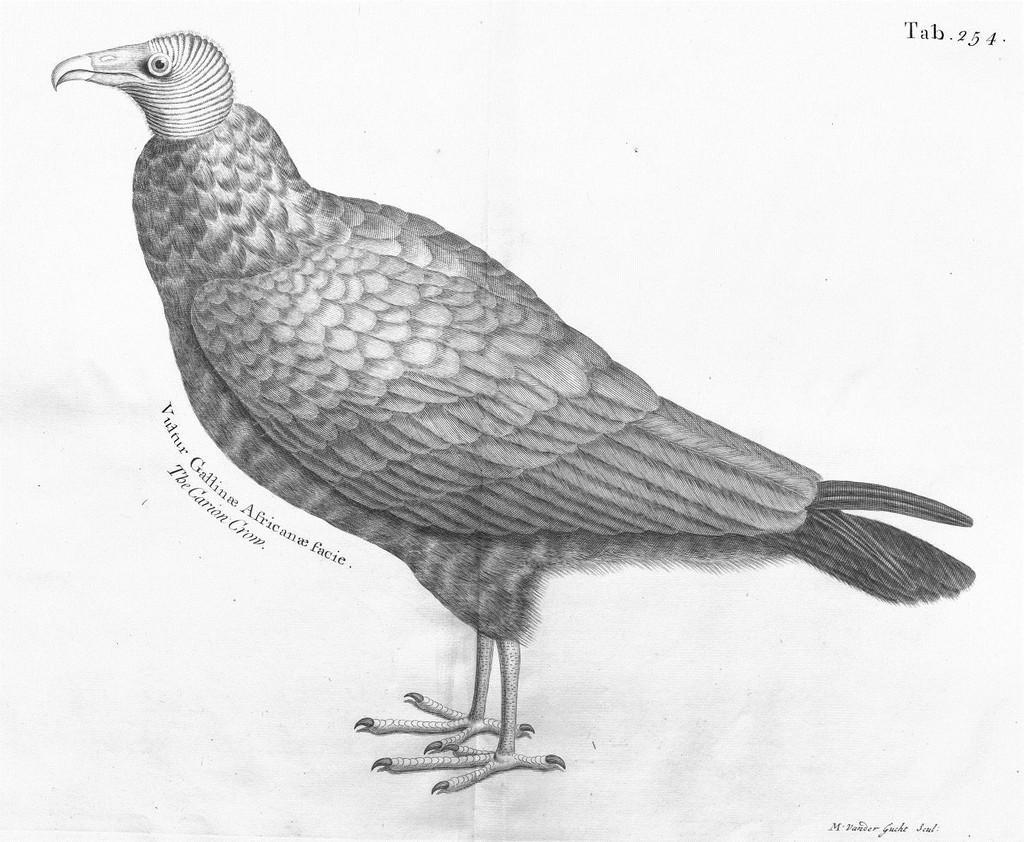In one or two sentences, can you explain what this image depicts? In this image I can see depiction picture of a bird. I can also see something is written on the left side and on the top right corner. 